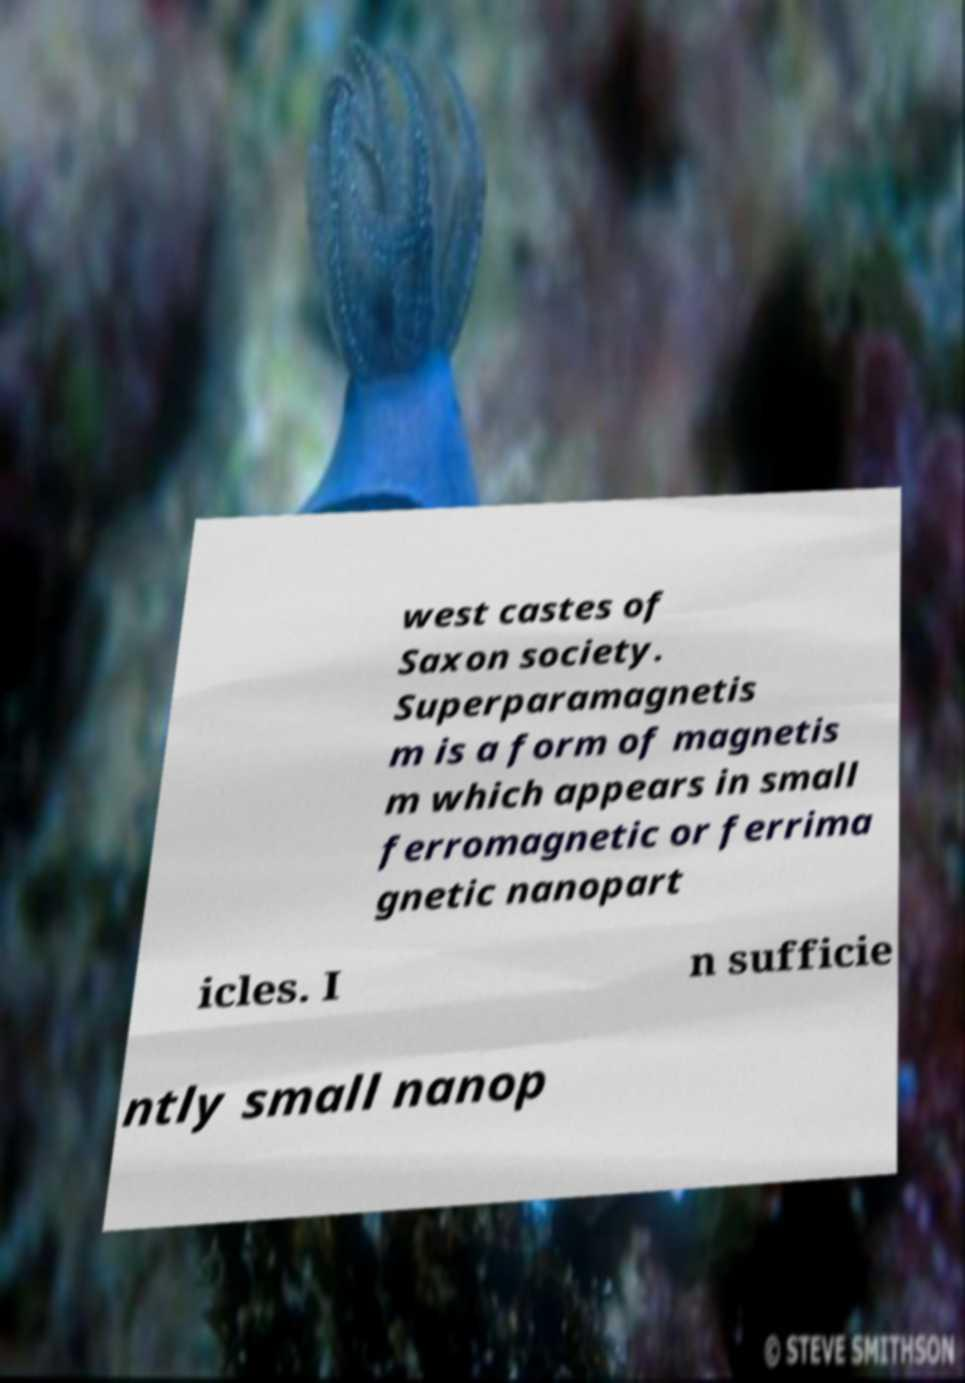Please read and relay the text visible in this image. What does it say? west castes of Saxon society. Superparamagnetis m is a form of magnetis m which appears in small ferromagnetic or ferrima gnetic nanopart icles. I n sufficie ntly small nanop 